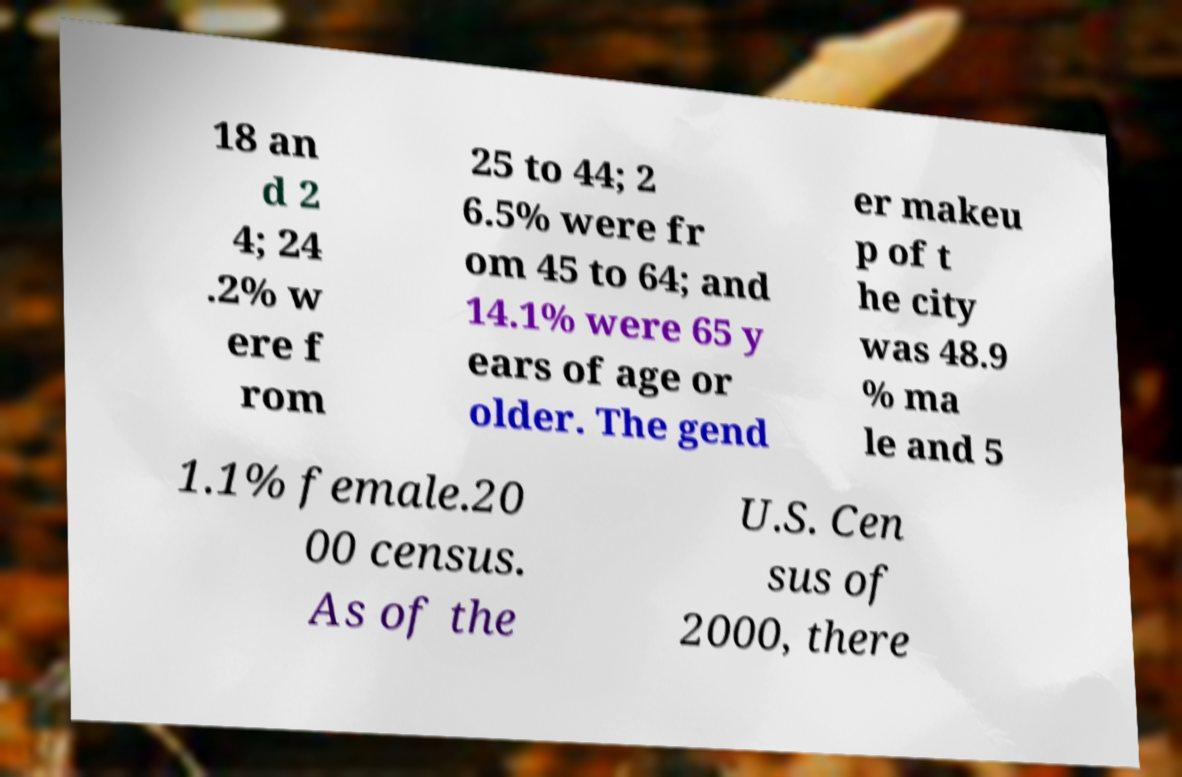Could you extract and type out the text from this image? 18 an d 2 4; 24 .2% w ere f rom 25 to 44; 2 6.5% were fr om 45 to 64; and 14.1% were 65 y ears of age or older. The gend er makeu p of t he city was 48.9 % ma le and 5 1.1% female.20 00 census. As of the U.S. Cen sus of 2000, there 